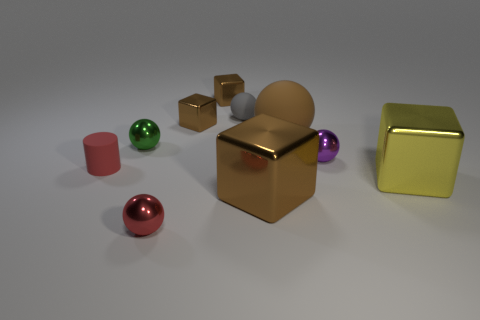Subtract all big balls. How many balls are left? 4 Add 5 large green spheres. How many large green spheres exist? 5 Subtract all green spheres. How many spheres are left? 4 Subtract 1 brown blocks. How many objects are left? 9 Subtract all blocks. How many objects are left? 6 Subtract 3 cubes. How many cubes are left? 1 Subtract all blue cubes. Subtract all yellow cylinders. How many cubes are left? 4 Subtract all purple cubes. How many purple spheres are left? 1 Subtract all cyan spheres. Subtract all red rubber cylinders. How many objects are left? 9 Add 3 blocks. How many blocks are left? 7 